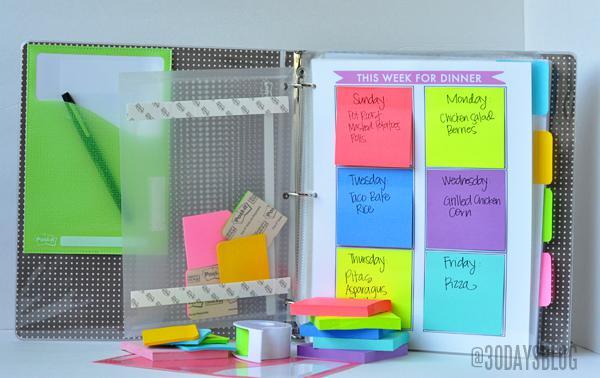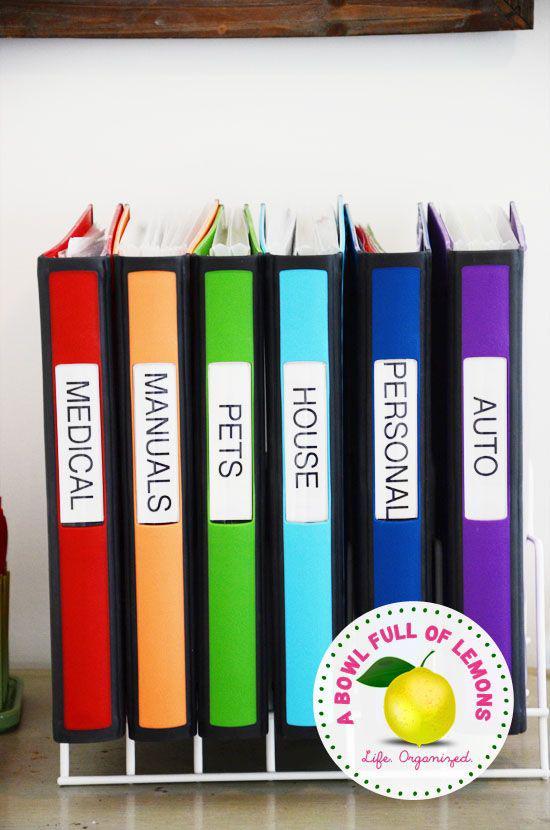The first image is the image on the left, the second image is the image on the right. Given the left and right images, does the statement "In one image, a row of notebooks in various colors stands on end, while a second image shows a single notebook open to show three rings and its contents." hold true? Answer yes or no. Yes. The first image is the image on the left, the second image is the image on the right. Given the left and right images, does the statement "An image shows one opened binder filled with supplies, including a pen." hold true? Answer yes or no. Yes. 